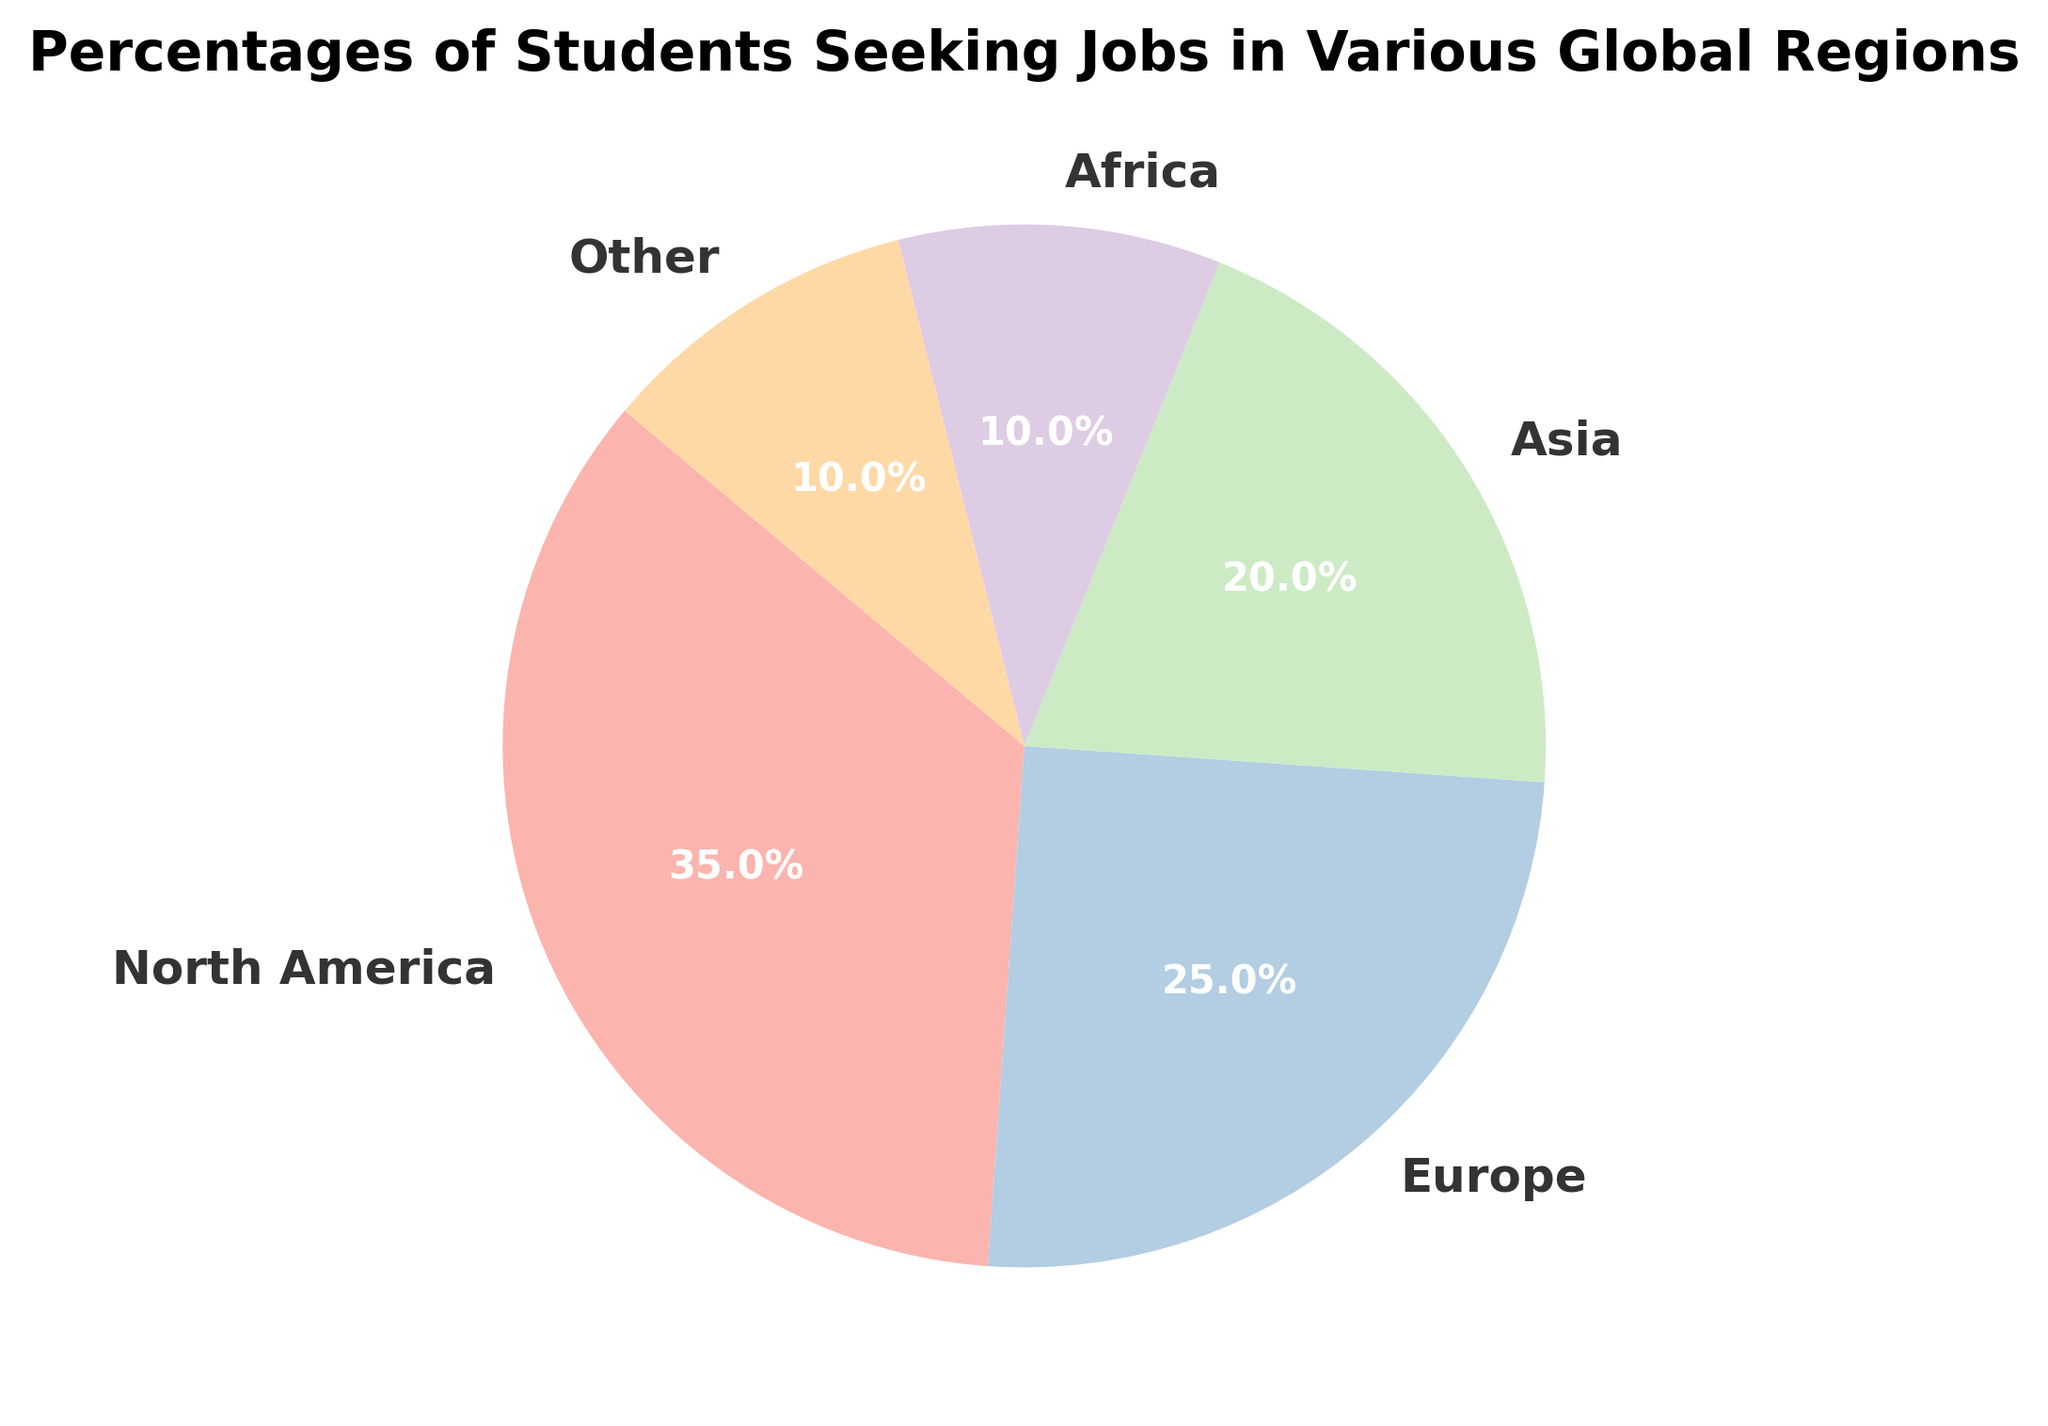What region has the highest percentage of students seeking jobs? First, look at all the sections of the pie chart and identify which one has the largest percentage. Referring to the data, the slice labeled "North America" is the largest, indicating that it has the highest percentage.
Answer: North America Which regions have the same percentage of students seeking jobs? Check the pie chart for regions with identical slices. Both "Africa" and "Other" share the same percentage size, which is 10%.
Answer: Africa and Other What is the combined percentage of students seeking jobs in Europe and Asia? Locate the slices labeled "Europe" and "Asia" on the pie chart and add their percentages. From the given data, Europe is 25% and Asia is 20%, so their combined percentage is 25% + 20% = 45%.
Answer: 45% How does the percentage of students seeking jobs in North America compare to those in Europe? Identify both percentages from the pie chart. North America has 35% and Europe has 25%. Comparing these values, North America's percentage is 10% higher than Europe's.
Answer: 10% higher Which region has the least percentage more than the region with the least percentage? Check the pie chart for the smallest slice, which represents 10% (Africa and Other). Then identify the next smallest slice, which is Asia at 20%. The difference between these two is 20% - 10% = 10%.
Answer: 10% What is the average percentage of students seeking jobs in North America, Europe, and Asia? Sum the percentages of North America, Europe, and Asia, and divide by 3. That would be (35% + 25% + 20%) / 3 = 26.67%.
Answer: 26.67% Is the percentage of students seeking jobs in Africa greater than in Other? Observe the pie chart slices for Africa and Other, which are visually the same. Both regions have 10%, so their percentages are equal.
Answer: No What is the sum of the percentages of students seeking jobs in regions other than North America? Find the percentages for Europe, Asia, Africa, and Other and sum them up. Europe is 25%, Asia is 20%, Africa is 10%, Other is 10%. So, the sum is 25% + 20% + 10% + 10% = 65%.
Answer: 65% By how much does the percentage of students seeking jobs in North America exceed the combined percentage of those in Africa and Other? Calculate the sum of percentages for Africa and Other: 10% + 10% = 20%. Then find the difference between North America's 35% and this combined percentage: 35% - 20% = 15%.
Answer: 15% Which region in the pie chart uses the pastel color corresponding to the largest slice? The pie chart's largest slice is North America, which is typically colored using the first color in the pastel palette. Since we do not know the exact hues used, it usually aligns with a primary pastel color representing the largest section.
Answer: North America 